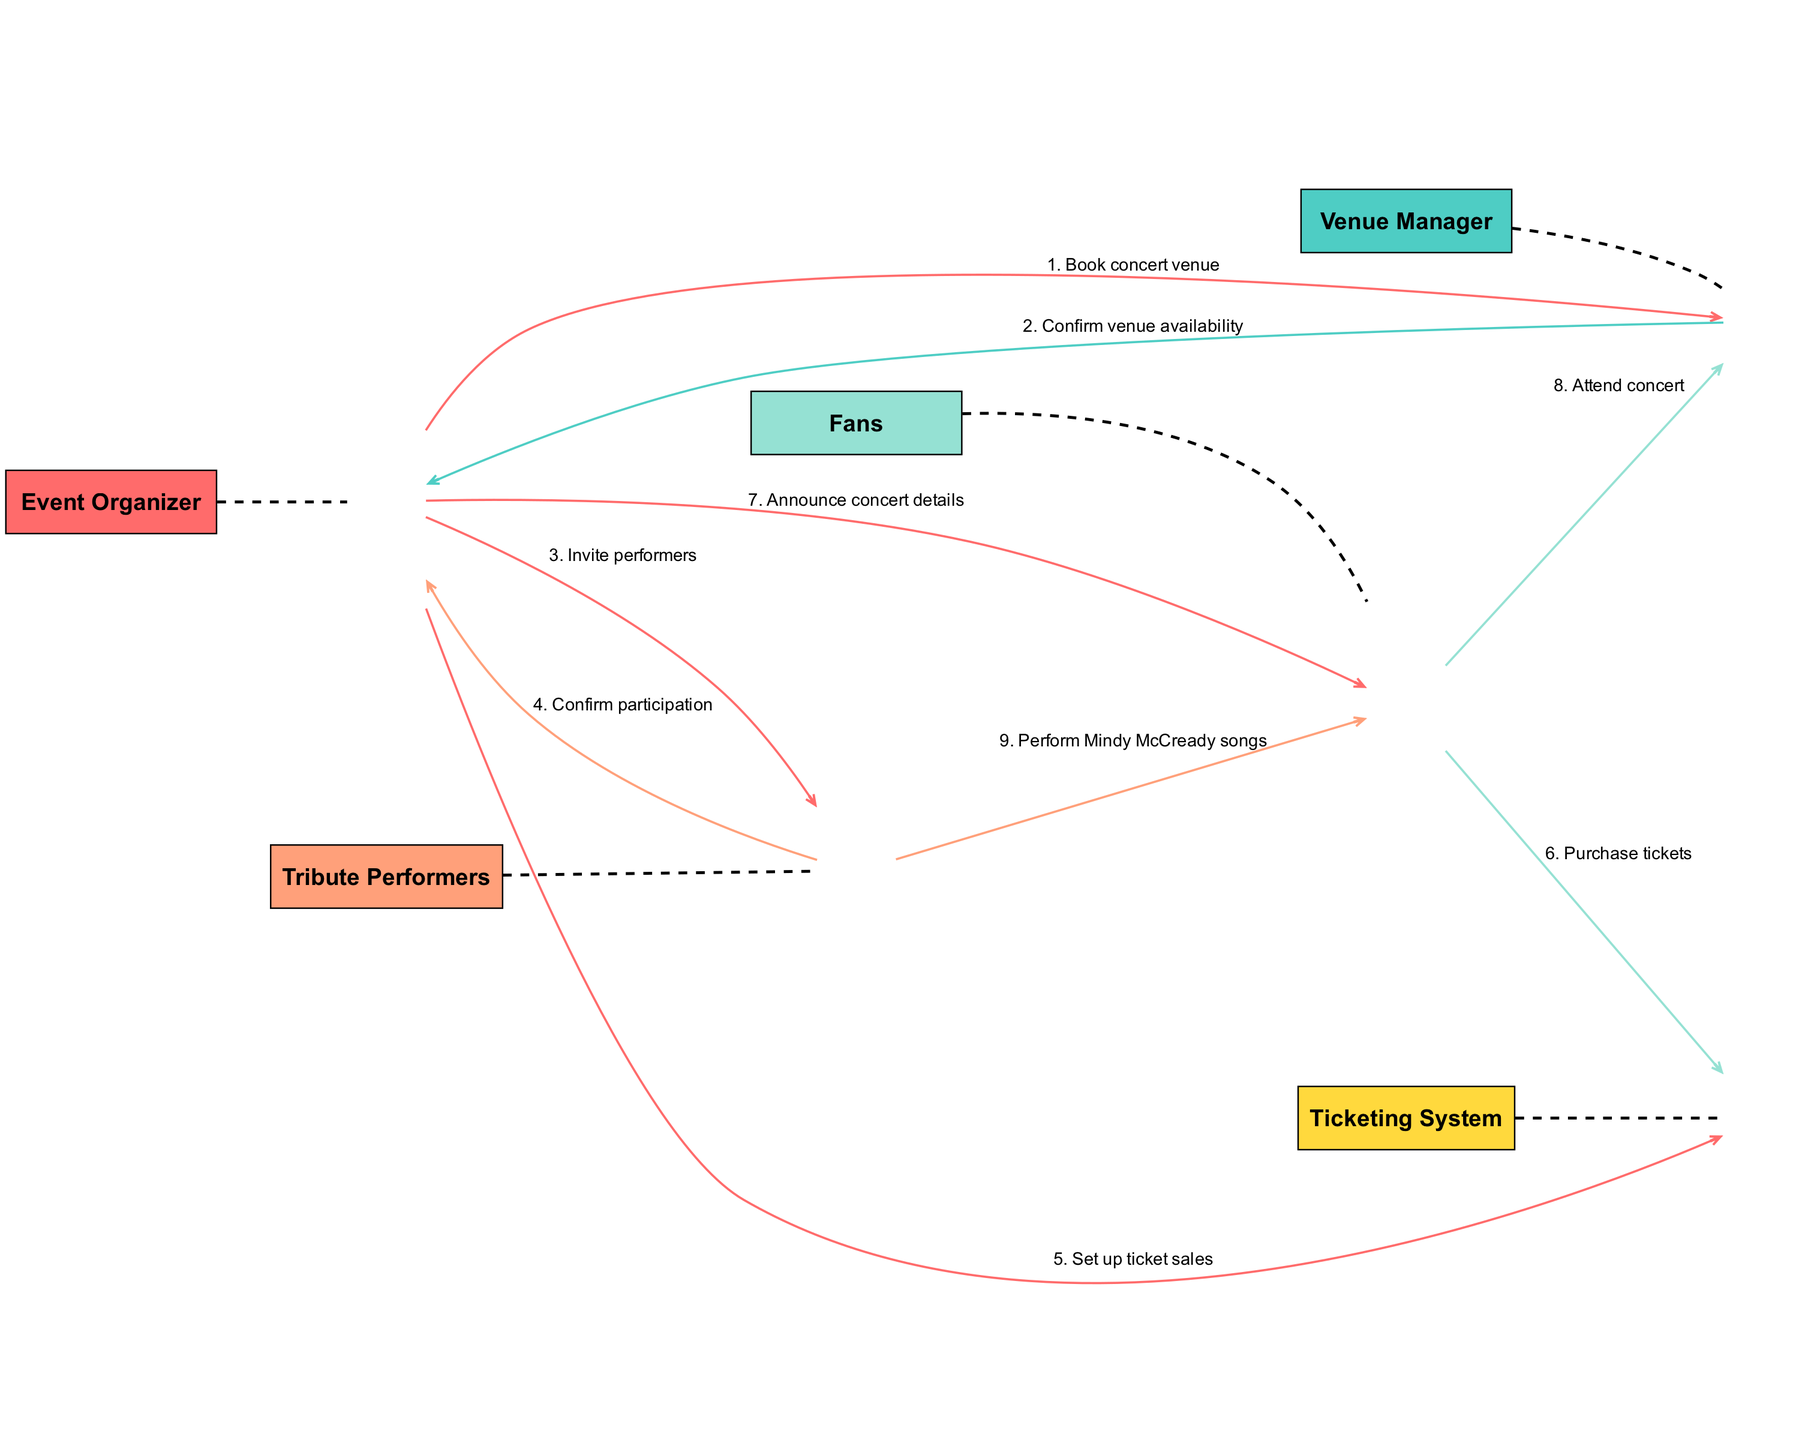What are the actors involved in the diagram? The actors listed in the diagram are the Event Organizer, Venue Manager, Tribute Performers, Fans, and Ticketing System. These actors represent different roles interacting in the process of organizing the tribute concert.
Answer: Event Organizer, Venue Manager, Tribute Performers, Fans, Ticketing System How many interactions are there between the actors? By reviewing the interactions listed in the diagram, there are a total of 8 interactions that depict the communication and flow between the actors involved in organizing the concert.
Answer: 8 Who is responsible for confirming venue availability? The Venue Manager is responsible for confirming the venue's availability after receiving a request from the Event Organizer to book the concert venue. This interaction shows the direct communication between these two actors.
Answer: Venue Manager What message does the Event Organizer send to the Tribute Performers? The Event Organizer sends the message "Invite performers" to the Tribute Performers as part of the process of organizing the concert. This indicates the Event Organizer's initiative to include performers in the event.
Answer: Invite performers What is the order of the first two interactions? The first interaction is from the Event Organizer to the Venue Manager to book the concert venue, and the second interaction is the Venue Manager confirming venue availability back to the Event Organizer, establishing a sequential flow of planning.
Answer: Book concert venue, Confirm venue availability Which actors are involved in the ticket purchasing process? The Fans and Ticketing System are involved in the ticket purchasing process, where Fans communicate with the Ticketing System to purchase tickets for the concert. This showcases the transaction aspect of the event.
Answer: Fans, Ticketing System How do Fans interact with the Venue Manager? Fans interact with the Venue Manager by attending the concert, indicating that the Fans follow through with their plans and the venue's management after purchasing tickets. This connects the activity of ticket purchase with the physical attendance at the concert.
Answer: Attend concert Who delivers the concert details to the Fans? The Event Organizer is responsible for delivering the concert details to the Fans, ensuring that they are informed about the event they are participating in. This demonstrates the Event Organizer's role in communication and event promotion.
Answer: Event Organizer 